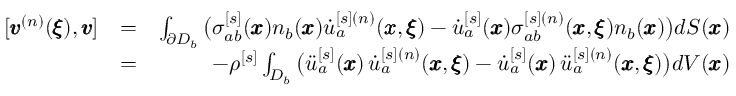Convert formula to latex. <formula><loc_0><loc_0><loc_500><loc_500>\begin{array} { r l r } { [ { \pm b v } ^ { ( n ) } ( { \pm b \xi } ) , { \pm b v } ] } & { = } & { \int _ { \partial D _ { b } } \left ( \sigma _ { a b } ^ { [ s ] } ( { \pm b x } ) n _ { b } ( { \pm b x } ) \dot { u } _ { a } ^ { [ s ] ( n ) } ( { \pm b x } , { \pm b \xi } ) - \dot { u } _ { a } ^ { [ s ] } ( { \pm b x } ) \sigma _ { a b } ^ { [ s ] ( n ) } ( { \pm b x } , { \pm b \xi } ) n _ { b } ( { \pm b x } ) \right ) d S ( { \pm b x } ) } \\ & { = } & { - \rho ^ { [ s ] } \int _ { D _ { b } } \left ( \ddot { u } _ { a } ^ { [ s ] } ( { \pm b x } ) \, \dot { u } _ { a } ^ { [ s ] ( n ) } ( { \pm b x } , { \pm b \xi } ) - \dot { u } _ { a } ^ { [ s ] } ( { \pm b x } ) \, \ddot { u } _ { a } ^ { [ s ] ( n ) } ( { \pm b x } , { \pm b \xi } ) \right ) d V ( { \pm b x } ) } \end{array}</formula> 